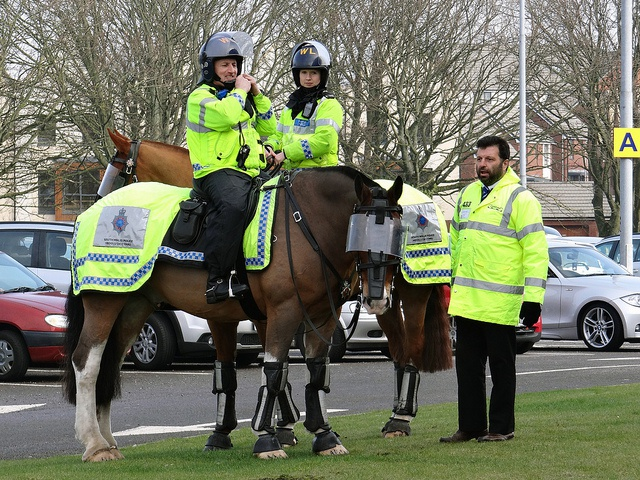Describe the objects in this image and their specific colors. I can see horse in darkgray, black, and gray tones, people in darkgray, black, khaki, and lightgreen tones, horse in darkgray, black, gray, beige, and maroon tones, people in darkgray, black, lime, and yellow tones, and car in darkgray, lavender, black, and gray tones in this image. 